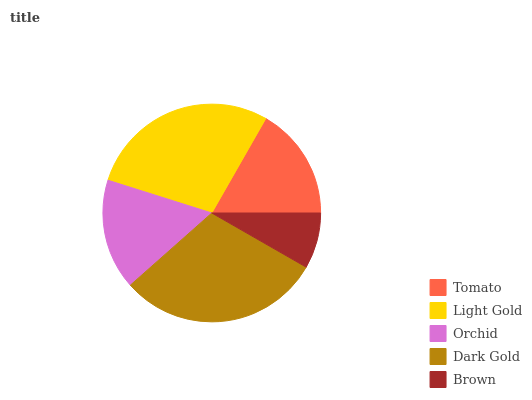Is Brown the minimum?
Answer yes or no. Yes. Is Dark Gold the maximum?
Answer yes or no. Yes. Is Light Gold the minimum?
Answer yes or no. No. Is Light Gold the maximum?
Answer yes or no. No. Is Light Gold greater than Tomato?
Answer yes or no. Yes. Is Tomato less than Light Gold?
Answer yes or no. Yes. Is Tomato greater than Light Gold?
Answer yes or no. No. Is Light Gold less than Tomato?
Answer yes or no. No. Is Tomato the high median?
Answer yes or no. Yes. Is Tomato the low median?
Answer yes or no. Yes. Is Brown the high median?
Answer yes or no. No. Is Light Gold the low median?
Answer yes or no. No. 